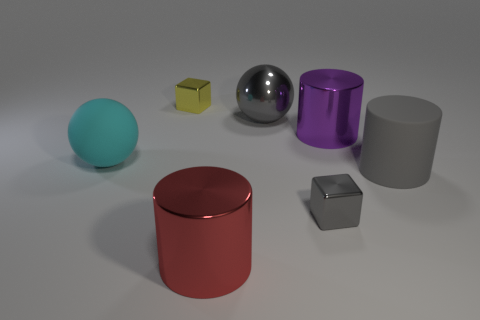Add 3 purple things. How many objects exist? 10 Subtract all spheres. How many objects are left? 5 Add 4 tiny blocks. How many tiny blocks exist? 6 Subtract 0 brown blocks. How many objects are left? 7 Subtract all big metallic balls. Subtract all large brown cylinders. How many objects are left? 6 Add 1 large purple shiny things. How many large purple shiny things are left? 2 